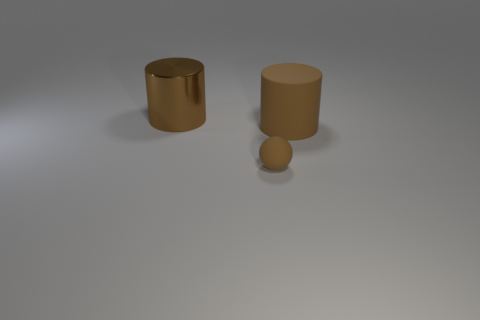Add 3 large purple matte objects. How many objects exist? 6 Subtract all cylinders. How many objects are left? 1 Subtract all tiny spheres. Subtract all metallic cylinders. How many objects are left? 1 Add 3 brown cylinders. How many brown cylinders are left? 5 Add 2 large brown metallic things. How many large brown metallic things exist? 3 Subtract 0 green blocks. How many objects are left? 3 